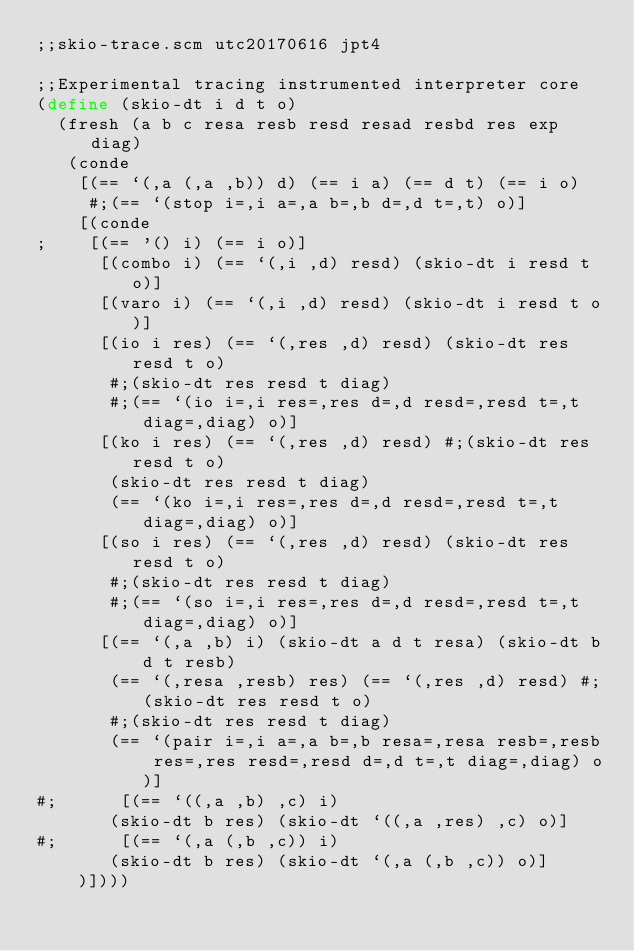<code> <loc_0><loc_0><loc_500><loc_500><_Scheme_>;;skio-trace.scm utc20170616 jpt4

;;Experimental tracing instrumented interpreter core
(define (skio-dt i d t o)
  (fresh (a b c resa resb resd resad resbd res exp diag)
   (conde
    [(== `(,a (,a ,b)) d) (== i a) (== d t) (== i o) 
     #;(== `(stop i=,i a=,a b=,b d=,d t=,t) o)]
    [(conde
;    [(== '() i) (== i o)]
      [(combo i) (== `(,i ,d) resd) (skio-dt i resd t o)]
      [(varo i) (== `(,i ,d) resd) (skio-dt i resd t o)]
      [(io i res) (== `(,res ,d) resd) (skio-dt res resd t o) 
       #;(skio-dt res resd t diag)
       #;(== `(io i=,i res=,res d=,d resd=,resd t=,t diag=,diag) o)]
      [(ko i res) (== `(,res ,d) resd) #;(skio-dt res resd t o) 
       (skio-dt res resd t diag)
       (== `(ko i=,i res=,res d=,d resd=,resd t=,t diag=,diag) o)]
      [(so i res) (== `(,res ,d) resd) (skio-dt res resd t o) 
       #;(skio-dt res resd t diag)
       #;(== `(so i=,i res=,res d=,d resd=,resd t=,t diag=,diag) o)]
      [(== `(,a ,b) i) (skio-dt a d t resa) (skio-dt b d t resb) 
       (== `(,resa ,resb) res) (== `(,res ,d) resd) #;(skio-dt res resd t o)
       #;(skio-dt res resd t diag)
       (== `(pair i=,i a=,a b=,b resa=,resa resb=,resb res=,res resd=,resd d=,d t=,t diag=,diag) o)]
#;      [(== `((,a ,b) ,c) i)
       (skio-dt b res) (skio-dt `((,a ,res) ,c) o)]
#;      [(== `(,a (,b ,c)) i) 
       (skio-dt b res) (skio-dt `(,a (,b ,c)) o)]
    )])))
</code> 